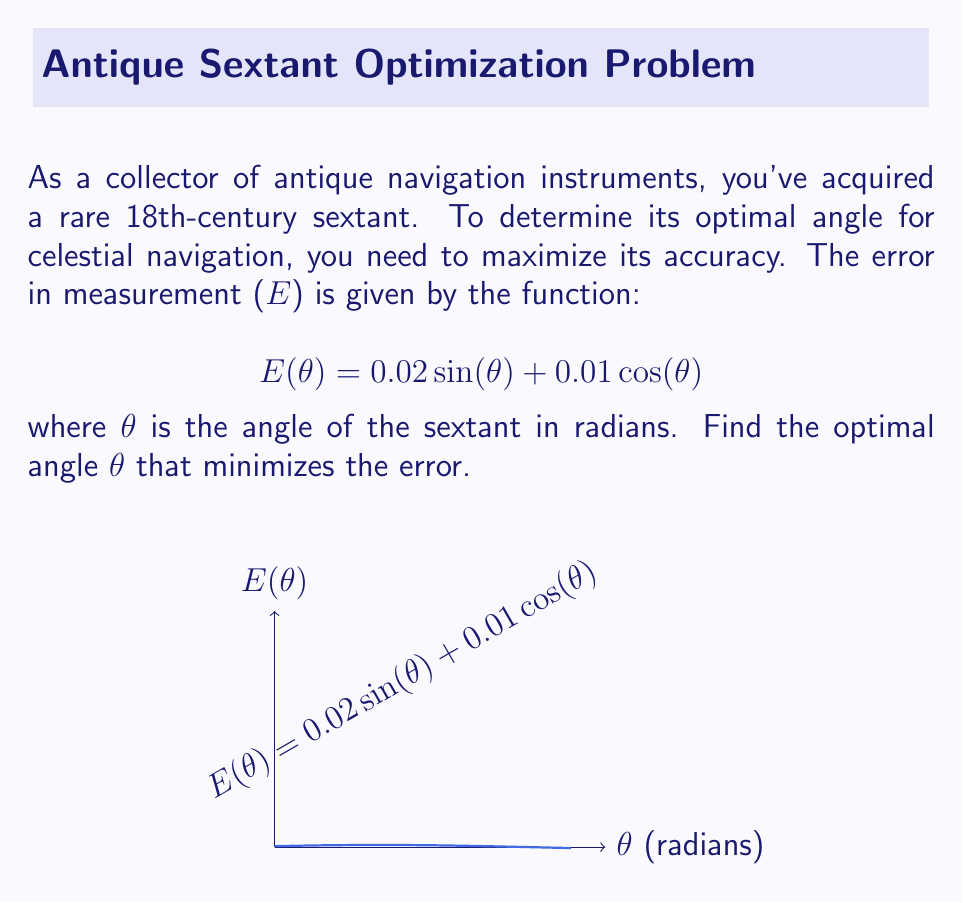Show me your answer to this math problem. To find the optimal angle that minimizes the error, we need to find the minimum of the function $E(\theta)$. We'll use the following steps:

1) Find the derivative of $E(\theta)$:
   $$E'(\theta) = 0.02\cos(\theta) - 0.01\sin(\theta)$$

2) Set the derivative equal to zero and solve for $\theta$:
   $$0.02\cos(\theta) - 0.01\sin(\theta) = 0$$

3) Divide both sides by $\cos(\theta)$ (assuming $\cos(\theta) \neq 0$):
   $$0.02 - 0.01\tan(\theta) = 0$$

4) Solve for $\tan(\theta)$:
   $$\tan(\theta) = 2$$

5) Take the inverse tangent of both sides:
   $$\theta = \arctan(2)$$

6) Convert to radians:
   $$\theta \approx 1.107 \text{ radians}$$

7) To confirm this is a minimum, check the second derivative:
   $$E''(\theta) = -0.02\sin(\theta) - 0.01\cos(\theta)$$
   At $\theta = \arctan(2)$, $E''(\theta) > 0$, confirming a minimum.

8) Convert to degrees for practical use:
   $$\theta \approx 63.4^\circ$$
Answer: $\theta = \arctan(2) \approx 1.107 \text{ radians } (63.4^\circ)$ 